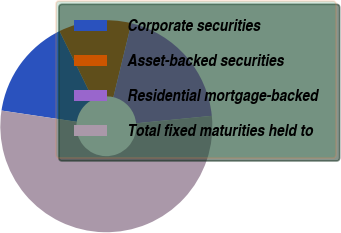Convert chart to OTSL. <chart><loc_0><loc_0><loc_500><loc_500><pie_chart><fcel>Corporate securities<fcel>Asset-backed securities<fcel>Residential mortgage-backed<fcel>Total fixed maturities held to<nl><fcel>15.36%<fcel>11.07%<fcel>19.64%<fcel>53.92%<nl></chart> 